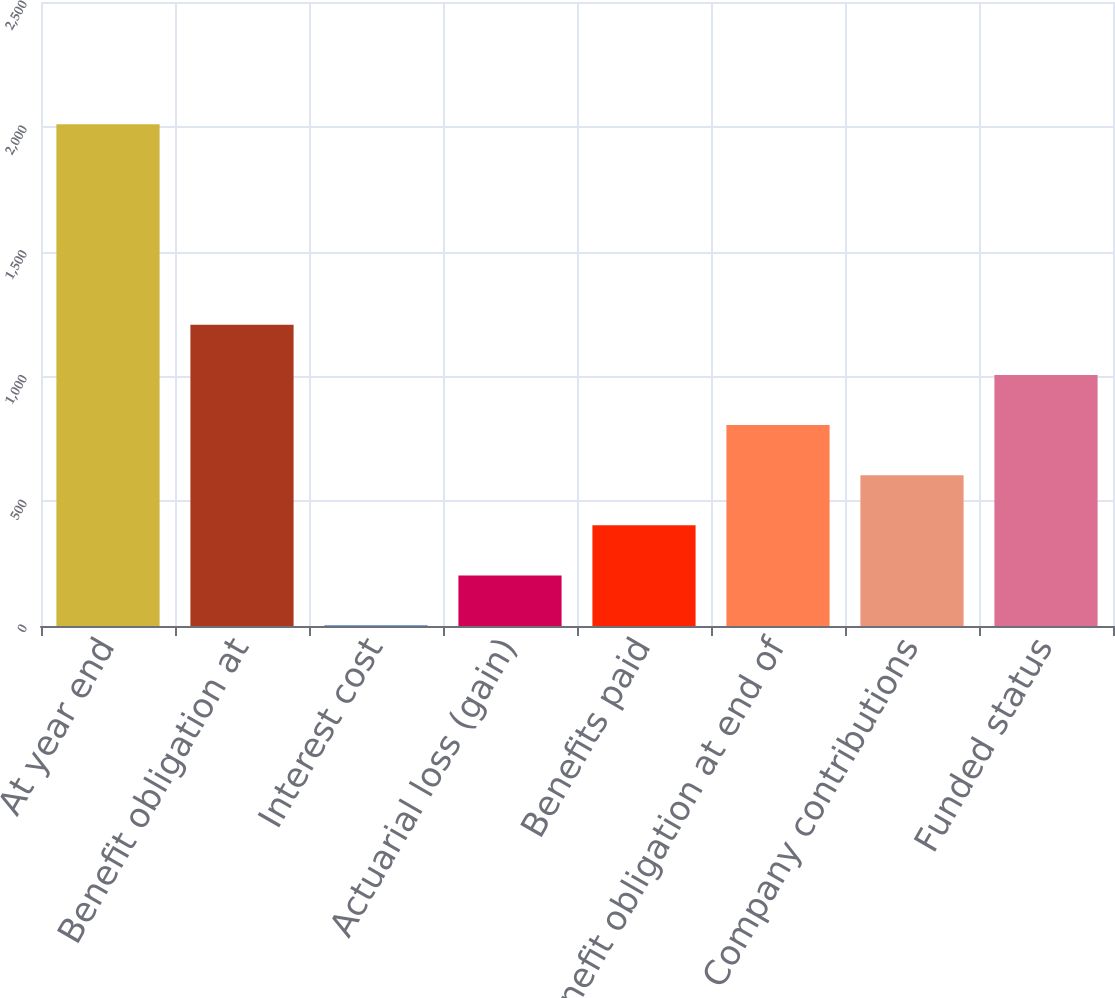Convert chart. <chart><loc_0><loc_0><loc_500><loc_500><bar_chart><fcel>At year end<fcel>Benefit obligation at<fcel>Interest cost<fcel>Actuarial loss (gain)<fcel>Benefits paid<fcel>Benefit obligation at end of<fcel>Company contributions<fcel>Funded status<nl><fcel>2010<fcel>1206.8<fcel>2<fcel>202.8<fcel>403.6<fcel>805.2<fcel>604.4<fcel>1006<nl></chart> 